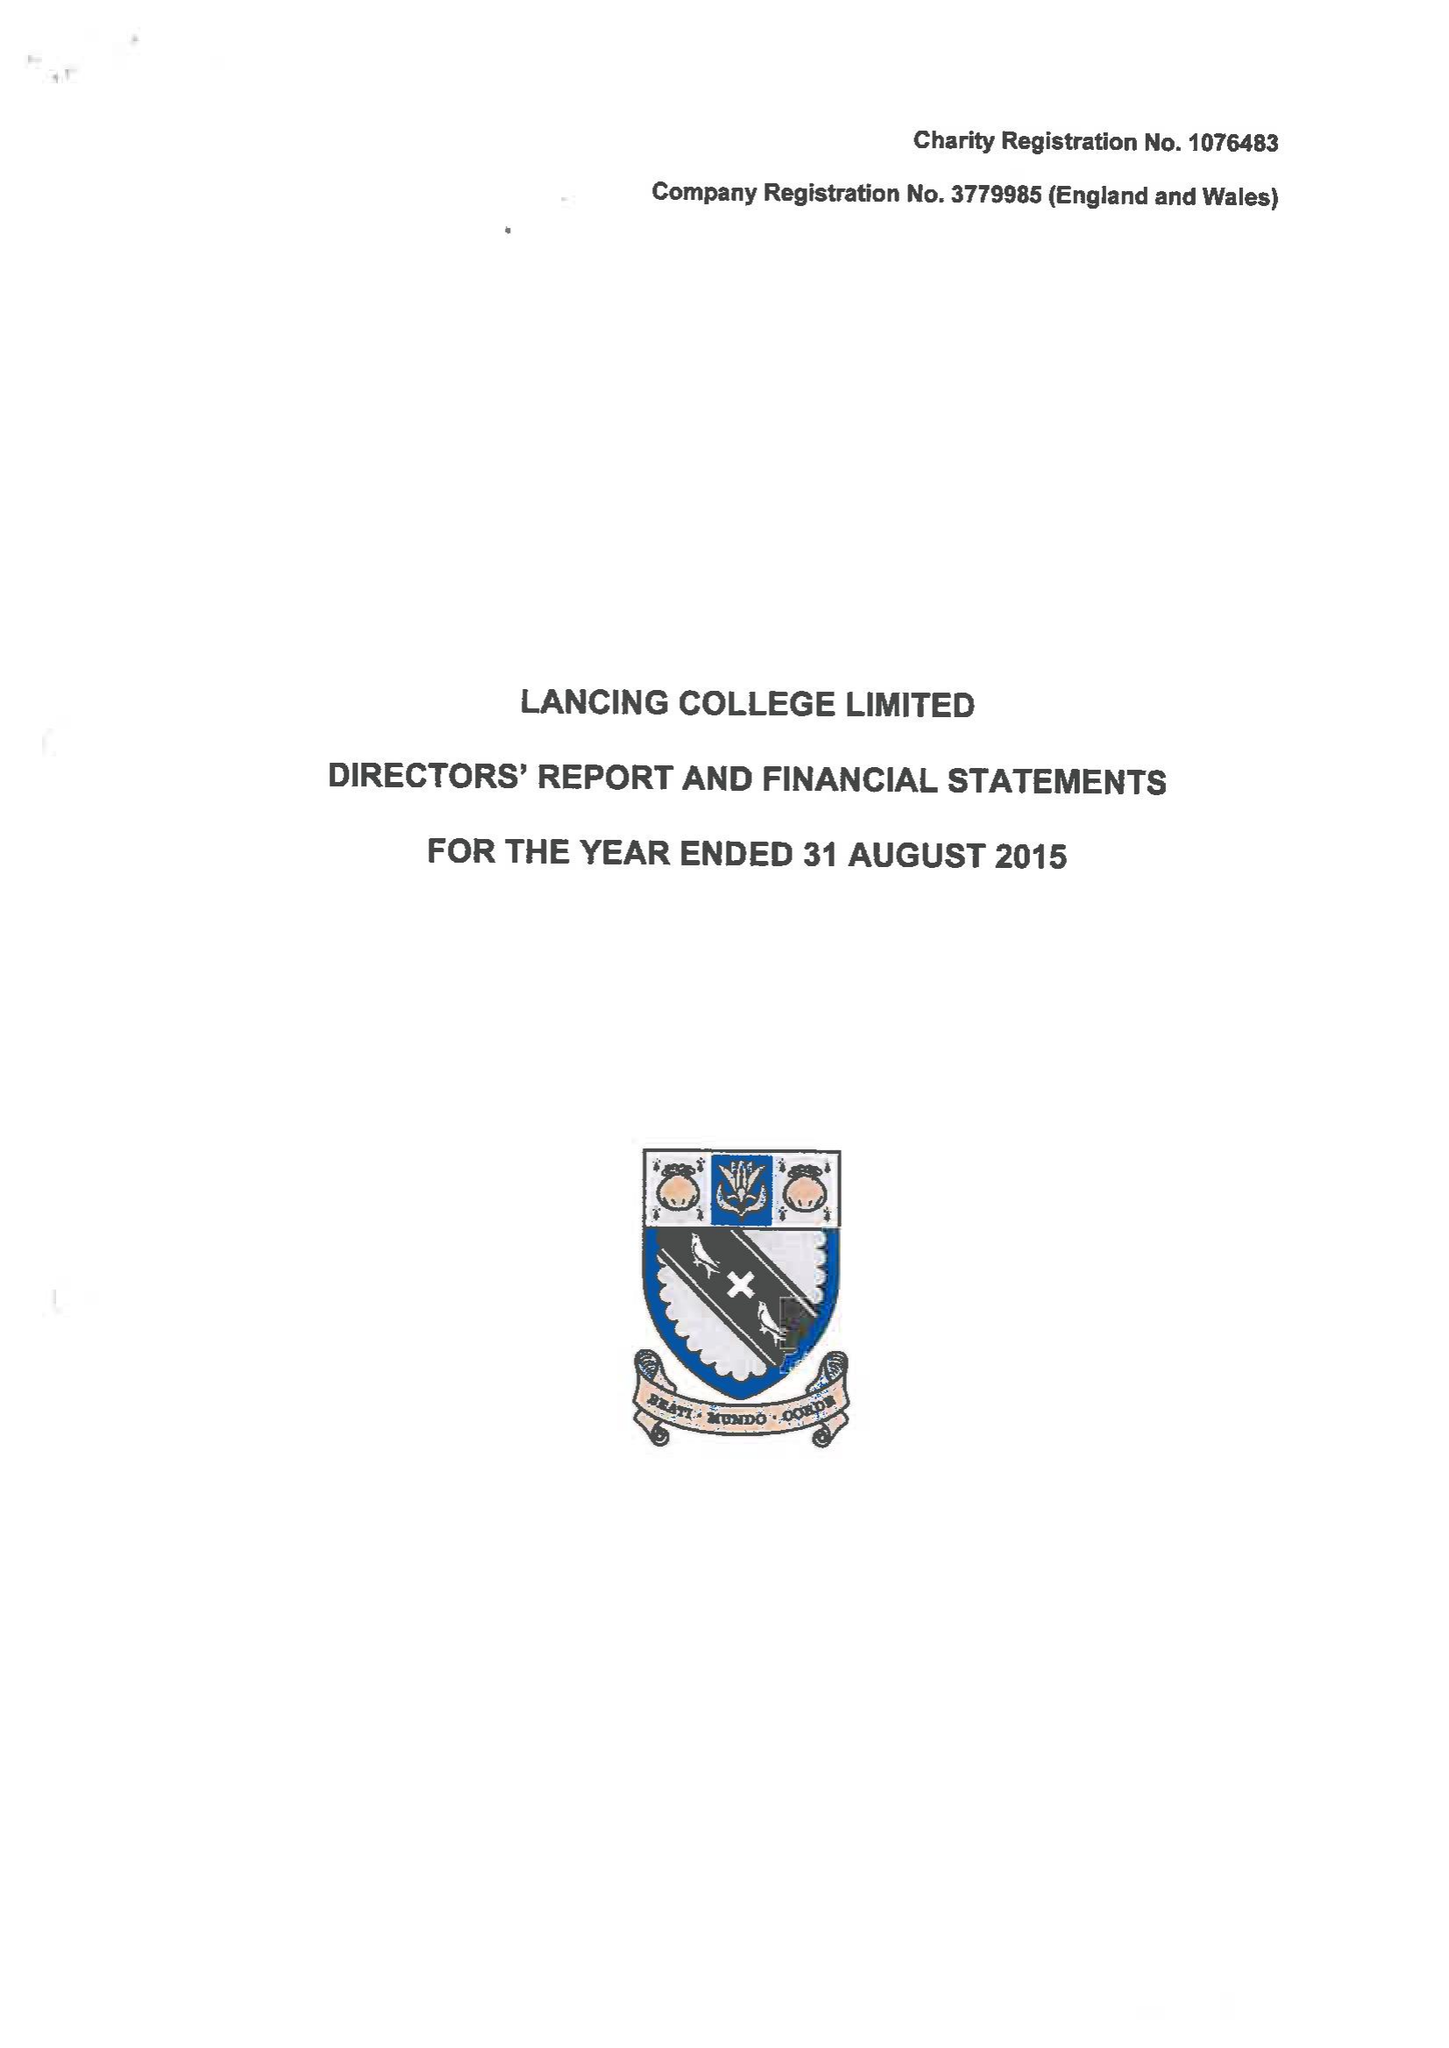What is the value for the address__post_town?
Answer the question using a single word or phrase. LANCING 